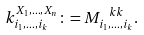Convert formula to latex. <formula><loc_0><loc_0><loc_500><loc_500>k _ { i _ { 1 } , \dots , i _ { k } } ^ { X _ { 1 } , \dots , X _ { n } } \colon = M _ { i _ { 1 } , \dots , i _ { k } } ^ { \ k k } .</formula> 